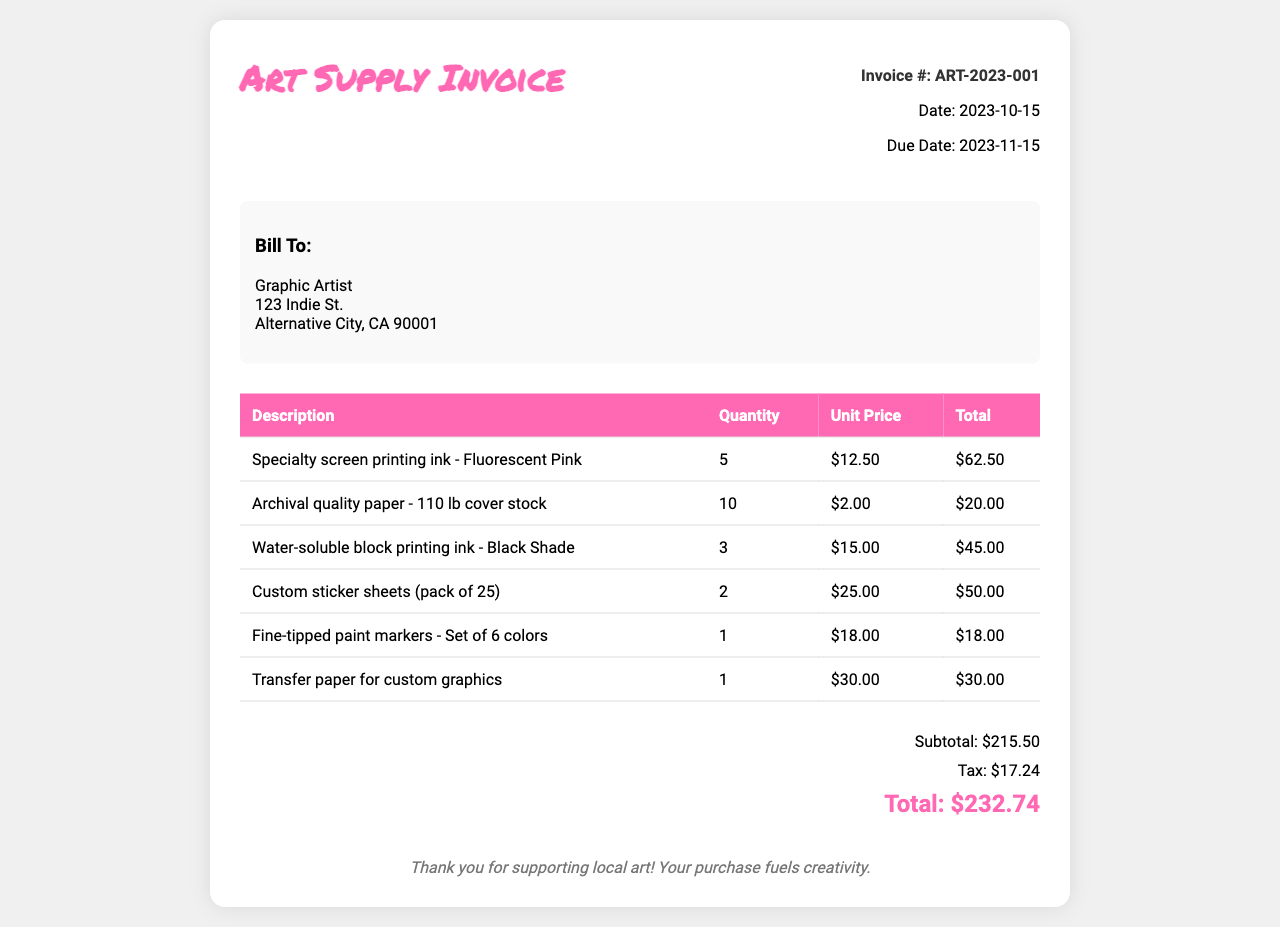what is the invoice number? The invoice number is clearly stated in the document as ART-2023-001.
Answer: ART-2023-001 what is the date of the invoice? The date is mentioned in the details section of the invoice as 2023-10-15.
Answer: 2023-10-15 how much is the subtotal? The subtotal is listed in the summary section of the invoice as $215.50.
Answer: $215.50 what is the total amount due? The total amount due is highlighted in the summary section as $232.74.
Answer: $232.74 how many units of fluorescent pink ink were purchased? The quantity of fluorescent pink ink is displayed in the table as 5.
Answer: 5 what type of paper was purchased? The type of paper purchased is mentioned in the invoice as archival quality paper - 110 lb cover stock.
Answer: archival quality paper - 110 lb cover stock how much tax was applied to the invoice? The tax amount is provided in the summary section as $17.24.
Answer: $17.24 how many custom sticker sheets were ordered? The number of custom sticker sheets ordered is shown in the table as 2.
Answer: 2 what is the due date for this invoice? The due date is specified in the invoice details section as 2023-11-15.
Answer: 2023-11-15 